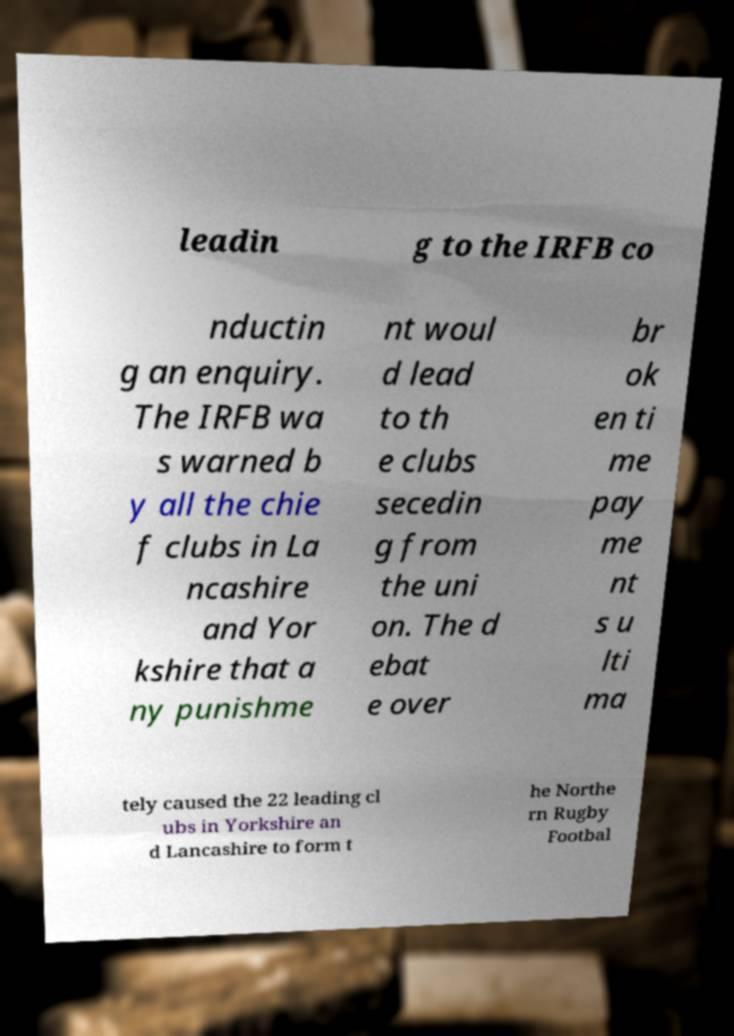There's text embedded in this image that I need extracted. Can you transcribe it verbatim? leadin g to the IRFB co nductin g an enquiry. The IRFB wa s warned b y all the chie f clubs in La ncashire and Yor kshire that a ny punishme nt woul d lead to th e clubs secedin g from the uni on. The d ebat e over br ok en ti me pay me nt s u lti ma tely caused the 22 leading cl ubs in Yorkshire an d Lancashire to form t he Northe rn Rugby Footbal 